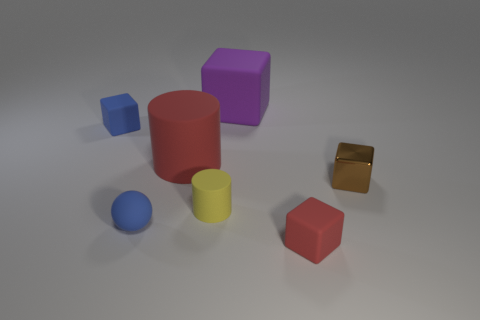There is a tiny thing behind the big red object; is it the same color as the matte sphere left of the yellow rubber thing?
Ensure brevity in your answer.  Yes. Are there any other things that have the same material as the small brown object?
Keep it short and to the point. No. The purple rubber object that is the same shape as the small brown object is what size?
Your response must be concise. Large. What is the material of the yellow object?
Provide a short and direct response. Rubber. What number of things are either objects on the left side of the metal object or red matte objects that are left of the purple matte thing?
Offer a terse response. 6. How many objects are either yellow metal objects or yellow rubber cylinders?
Your answer should be very brief. 1. What number of tiny yellow things are left of the matte cylinder that is to the left of the small yellow cylinder?
Provide a short and direct response. 0. How many other things are there of the same size as the purple block?
Offer a very short reply. 1. What is the size of the matte block that is the same color as the tiny matte ball?
Offer a terse response. Small. Do the red rubber object to the left of the small red rubber object and the yellow rubber object have the same shape?
Your answer should be very brief. Yes. 